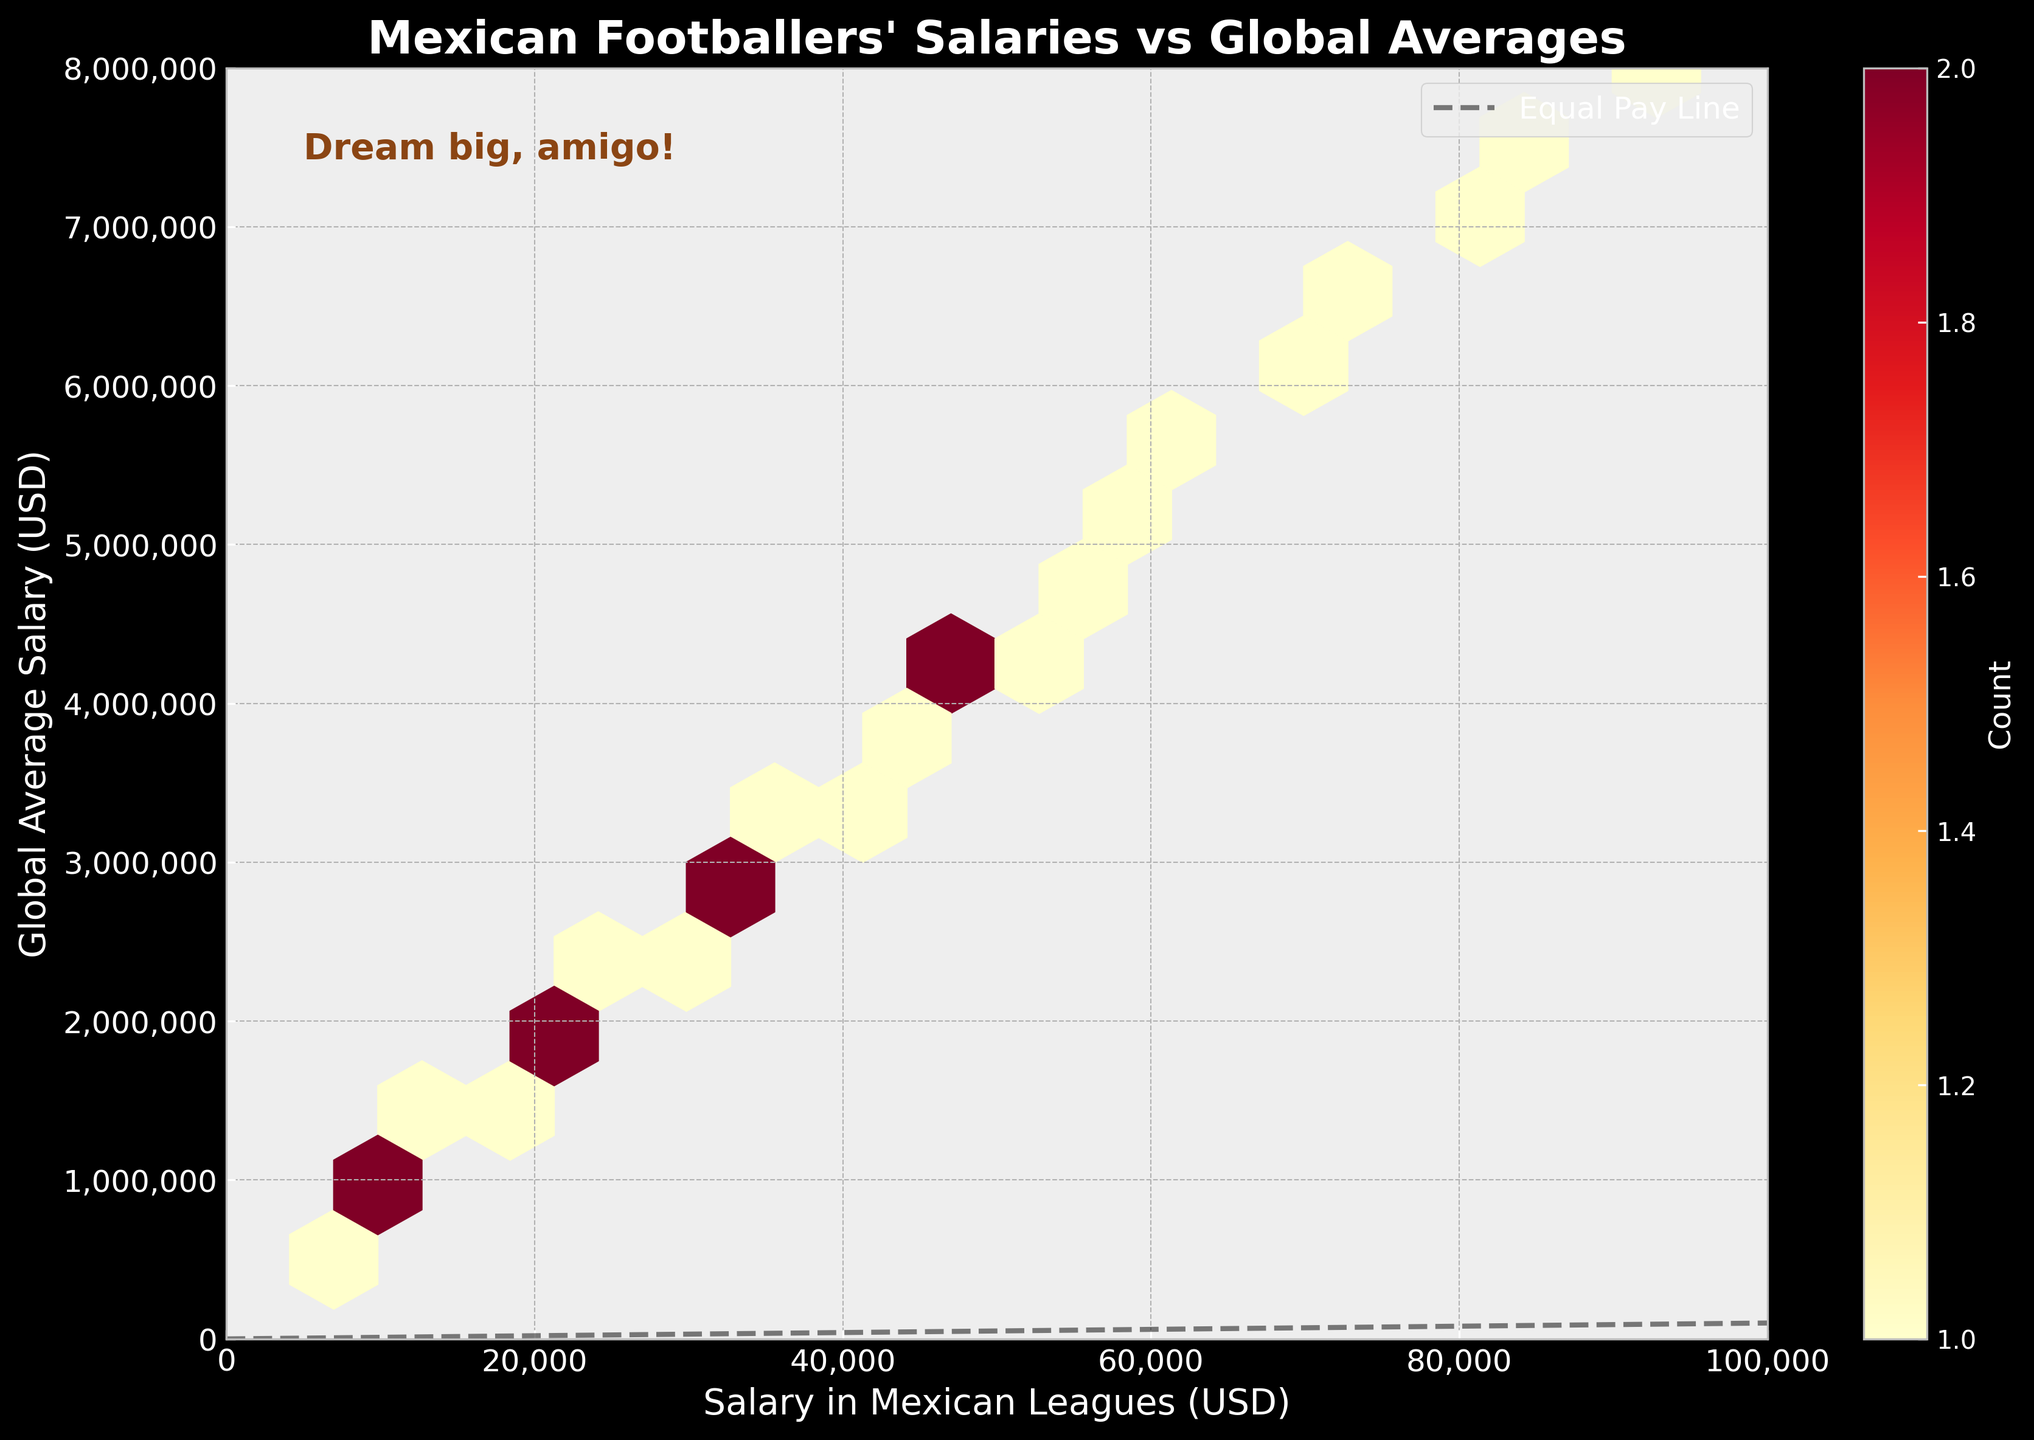What is the title of the hexbin plot? The title of the hexbin plot is displayed prominently at the top of the figure.
Answer: Mexican Footballers' Salaries vs Global Averages What does the color in the hexbin plot represent? The plot uses a color gradient (cmap 'YlOrRd'), ranging from yellow to red, to indicate the density or count of data points within each hexbin. The brighter the color, the higher the density or number of data points.
Answer: Density of data points What currency is used on the x-axis? The x-axis label indicates the currency used for salaries in Mexican leagues. It is denoted as "Salary in Mexican Leagues (USD)".
Answer: USD Which axis represents the global average salary? The y-axis is labeled "Global Average Salary (USD)" and thus represents the global average salaries.
Answer: y-axis What is the data range shown on the x-axis? By reviewing the x-axis, the range goes from 0 to 100,000 USD.
Answer: 0 to 100,000 USD What is the highest global average salary indicated on the y-axis? By checking the top end of the y-axis, it shows the highest value which is 8,000,000 USD.
Answer: 8,000,000 USD What does the diagonal dashed line represent? The diagonal dashed line represents the 'Equal Pay Line', where salaries in Mexican leagues would be equal to the global average salaries.
Answer: Equal Pay Line Where is the text annotation "Dream big, amigo!" located? The text annotation "Dream big, amigo!" is located at the top left corner of the plot area, which is inside the plot but not overlapping with data points.
Answer: Top left corner (inside plot) If a footballer in Mexican leagues earns 50,000 USD, what would be the corresponding global average salary approximately? By finding the x-value corresponding to 50,000 USD and checking the density or proximity to the equal pay line, the closest global average salary on the y-axis is around 2,500,000 USD.
Answer: 2,500,000 USD How does the average salary for Mexican footballers compare to the global average salary? By observing the density of hexagons and their position relative to the diagonal 'Equal Pay Line', it is evident that most Mexican footballers earn significantly less than the global average, as most points lie far below the line.
Answer: Mexican salaries are generally lower 